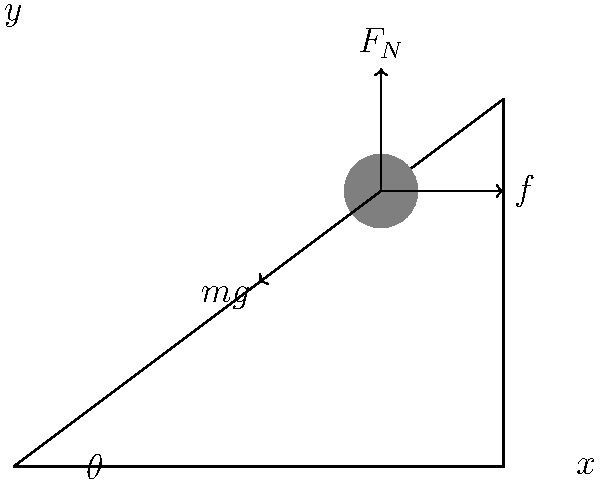As a senior IT manager collaborating on industry-wide projects, you're developing a physics simulation for a training program. The simulation involves an object on an inclined plane, as shown in the diagram. If the coefficient of friction between the object and the plane is $\mu = 0.3$, and the angle of inclination $\theta = 30°$, at what minimum acceleration would the object start sliding down the plane? Assume $g = 9.8 \text{ m/s}^2$. To solve this problem, we'll follow these steps:

1) First, let's identify the forces acting on the object:
   - Weight ($mg$)
   - Normal force ($F_N$)
   - Friction force ($f$)

2) Resolve the weight into components parallel and perpendicular to the inclined plane:
   - Parallel component: $mg \sin \theta$
   - Perpendicular component: $mg \cos \theta$

3) The normal force is equal to the perpendicular component of weight:
   $F_N = mg \cos \theta$

4) The maximum static friction force is given by:
   $f_{\text{max}} = \mu F_N = \mu mg \cos \theta$

5) For the object to be on the verge of sliding, the parallel component of weight must equal the maximum static friction:
   $mg \sin \theta = \mu mg \cos \theta$

6) If this equality is not met, we need to find the acceleration. The net force down the plane is:
   $F_{\text{net}} = mg \sin \theta - \mu mg \cos \theta$

7) Using Newton's Second Law, $F = ma$:
   $mg \sin \theta - \mu mg \cos \theta = ma$

8) Solve for $a$:
   $a = g(\sin \theta - \mu \cos \theta)$

9) Plug in the values:
   $a = 9.8(sin(30°) - 0.3 \cos(30°))$
   $a = 9.8(0.5 - 0.3 * 0.866) = 2.34 \text{ m/s}^2$

Therefore, the object would start sliding with a minimum acceleration of 2.34 m/s².
Answer: 2.34 m/s² 